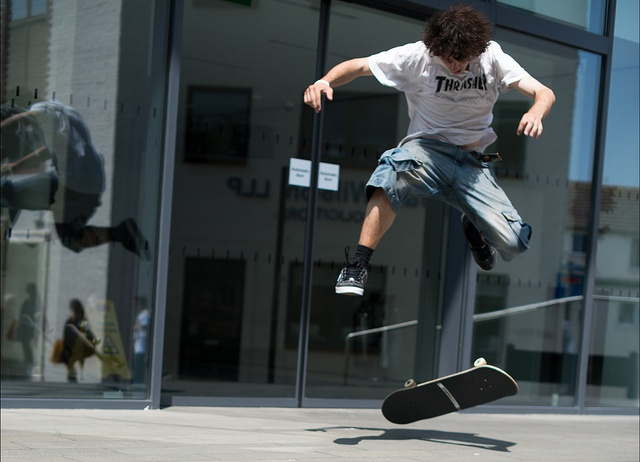Describe the objects in this image and their specific colors. I can see people in black, gray, lightgray, and darkgray tones, skateboard in black, gray, darkgray, and ivory tones, people in black and gray tones, people in black, gray, and blue tones, and people in black and gray tones in this image. 